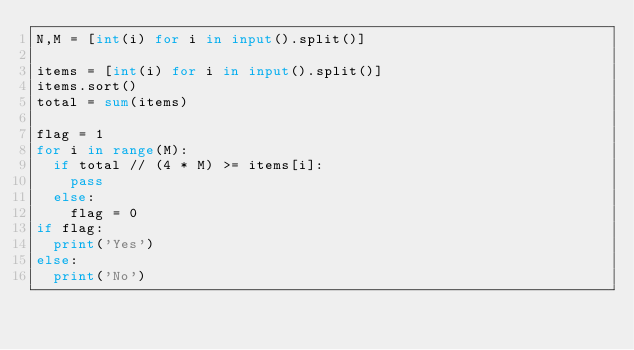<code> <loc_0><loc_0><loc_500><loc_500><_Python_>N,M = [int(i) for i in input().split()]

items = [int(i) for i in input().split()]
items.sort()
total = sum(items)

flag = 1
for i in range(M):
  if total // (4 * M) >= items[i]:
    pass
  else:
    flag = 0
if flag:
  print('Yes')
else:
  print('No')</code> 